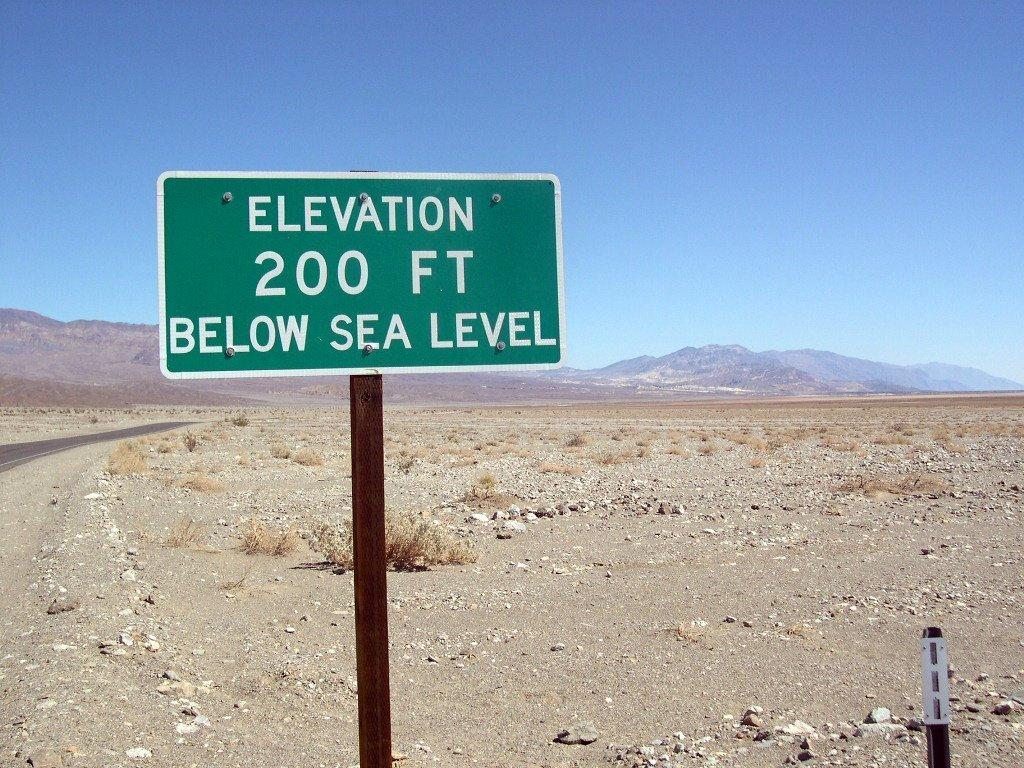<image>
Render a clear and concise summary of the photo. A green sign with Elevation 200 feet below sea level on it. 